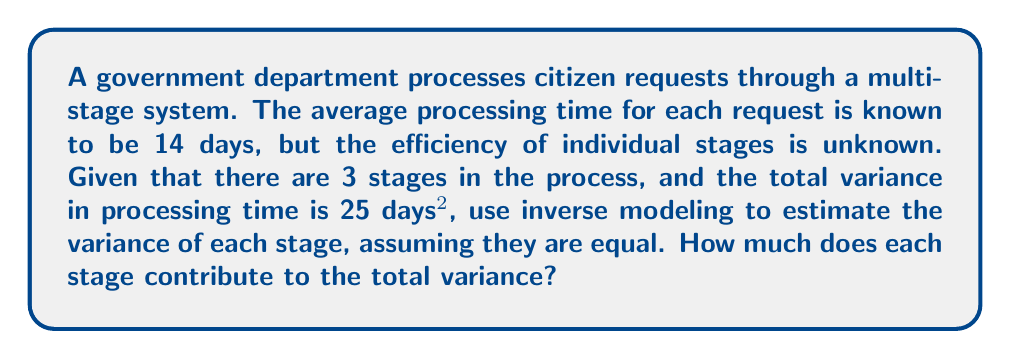Provide a solution to this math problem. To solve this problem, we'll use inverse modeling to estimate the variance of each stage in the process. Here's a step-by-step approach:

1. Let's define our variables:
   $n$ = number of stages = 3
   $\sigma_T^2$ = total variance = 25 days²
   $\sigma_i^2$ = variance of each individual stage (assumed equal)

2. In a multi-stage process with independent stages, the total variance is the sum of individual variances:

   $$\sigma_T^2 = \sum_{i=1}^n \sigma_i^2$$

3. Since we assume all stage variances are equal, we can simplify this to:

   $$\sigma_T^2 = n \cdot \sigma_i^2$$

4. Now, we can solve for $\sigma_i^2$:

   $$\sigma_i^2 = \frac{\sigma_T^2}{n}$$

5. Plugging in our known values:

   $$\sigma_i^2 = \frac{25}{3} \approx 8.33 \text{ days}^2$$

6. To find the contribution of each stage to the total variance, we divide the individual variance by the total variance:

   $$\text{Contribution} = \frac{\sigma_i^2}{\sigma_T^2} = \frac{8.33}{25} = \frac{1}{3} = 0.3333$$

7. Convert to a percentage:

   $$0.3333 \times 100\% = 33.33\%$$
Answer: 33.33% 